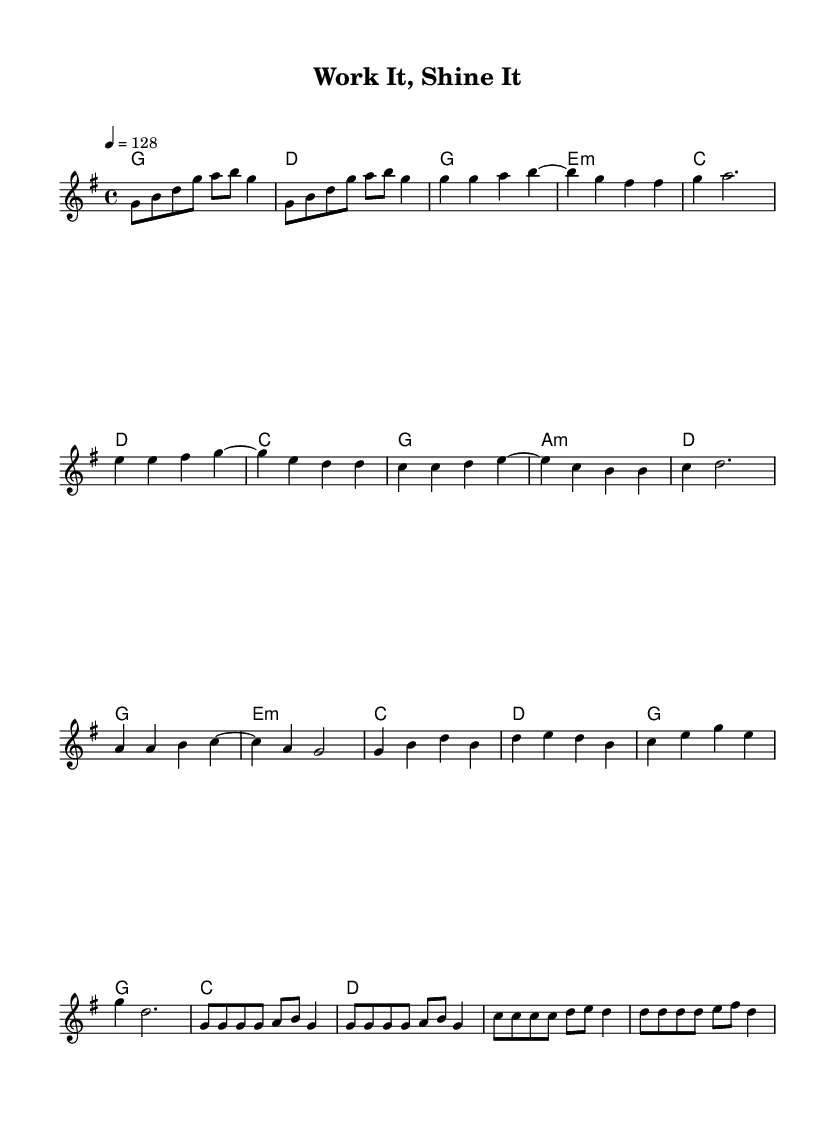What is the key signature of this music? The key signature shown at the beginning of the score indicates G major, which has one sharp (F#).
Answer: G major What is the time signature of this music? The time signature is visually indicated at the beginning of the sheet music as 4/4, meaning there are four beats per measure.
Answer: 4/4 What is the tempo marking for this piece? The tempo marking, found at the beginning, indicates a speed of 128 beats per minute, which is moderate-fast.
Answer: 128 What is the first chord in the piece? The first chord in the chord symbols section shows a G major chord, which is located right after the intro section.
Answer: G How many measures does the chorus section contain? By examining the melody and harmonies, the chorus consists of 4 measures as indicated by the structure on the sheet music.
Answer: 4 What type of chord is played during the verse? The chord symbols present throughout the verse indicate the presence of E minor chord, specifically indicated in the chord progression.
Answer: E minor What is a typical characteristic of K-Pop melodies seen in this piece? The melody features catchy hooks and repetitive phrases, which are typical of K-Pop, designed for engagement and enjoyment.
Answer: Catchy hooks 